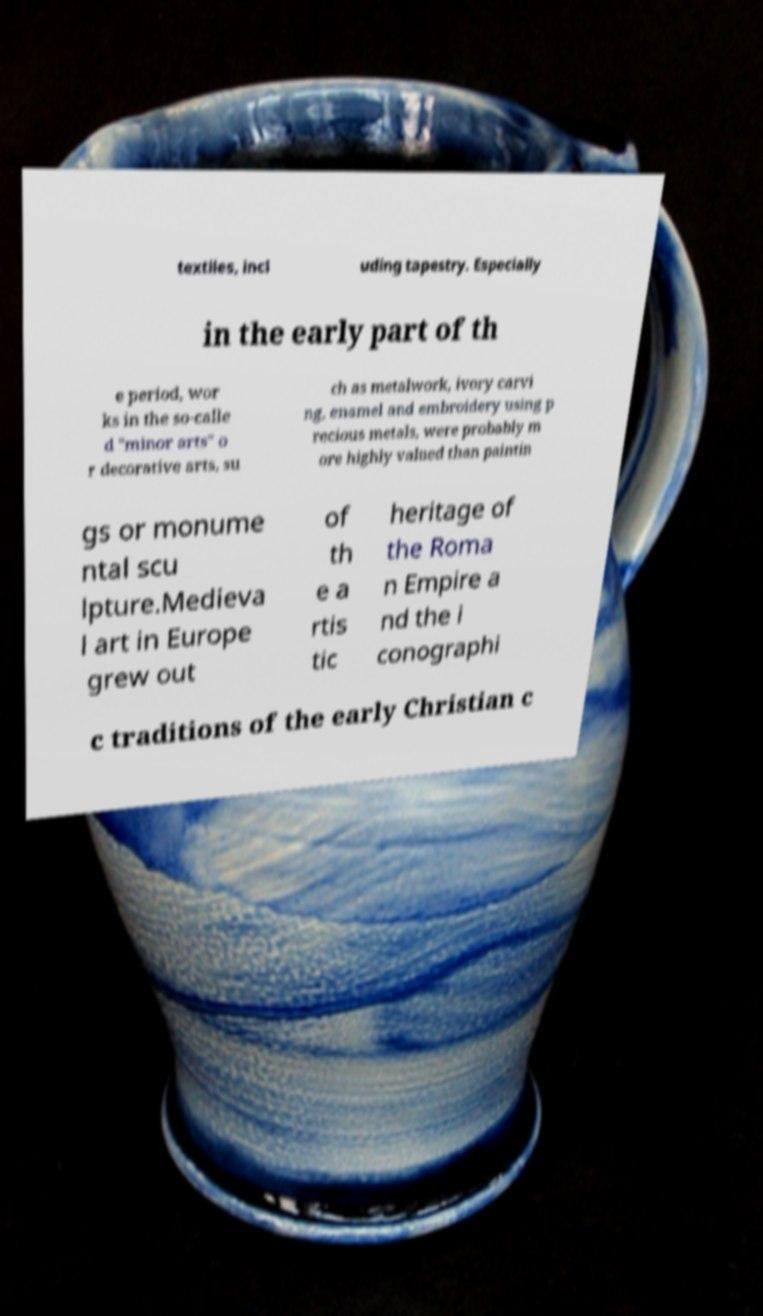Can you read and provide the text displayed in the image?This photo seems to have some interesting text. Can you extract and type it out for me? textiles, incl uding tapestry. Especially in the early part of th e period, wor ks in the so-calle d "minor arts" o r decorative arts, su ch as metalwork, ivory carvi ng, enamel and embroidery using p recious metals, were probably m ore highly valued than paintin gs or monume ntal scu lpture.Medieva l art in Europe grew out of th e a rtis tic heritage of the Roma n Empire a nd the i conographi c traditions of the early Christian c 